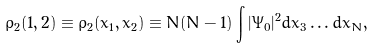<formula> <loc_0><loc_0><loc_500><loc_500>\rho _ { 2 } ( 1 , 2 ) \equiv \rho _ { 2 } ( x _ { 1 } , x _ { 2 } ) \equiv N ( N - 1 ) \int | \Psi _ { 0 } | ^ { 2 } d x _ { 3 } \dots d x _ { N } ,</formula> 